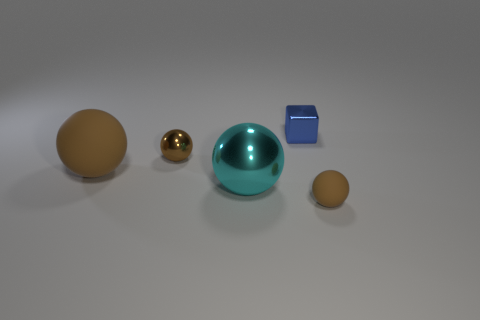Can you describe the objects and their arrangement? Certainly! We see a collection of objects, there's a large tan sphere far left, a smaller golden sphere, a sizeable teal sphere in the center, a small blue cube to the right of the teal sphere, and a smaller tan sphere far right. They're all laid out on a flat surface, seemingly in arbitrary spacing with no overlapping items.  What could these objects represent if we were to interpret their arrangement metaphorically? Metaphorically, these objects could represent a solar system with the large teal sphere at the center acting as the sun, the other spheres as planets, and the tiny blue cube could represent an anomaly or perhaps a spacecraft exploring the system.  If I were to add more objects to create a balanced composition, what would you suggest? To create a balanced composition, you might add another cube of a different color on the left side to mirror the blue one on the right, and perhaps a larger cube behind the teal sphere to give a sense of equilibrium and depth to the assortment of shapes. 